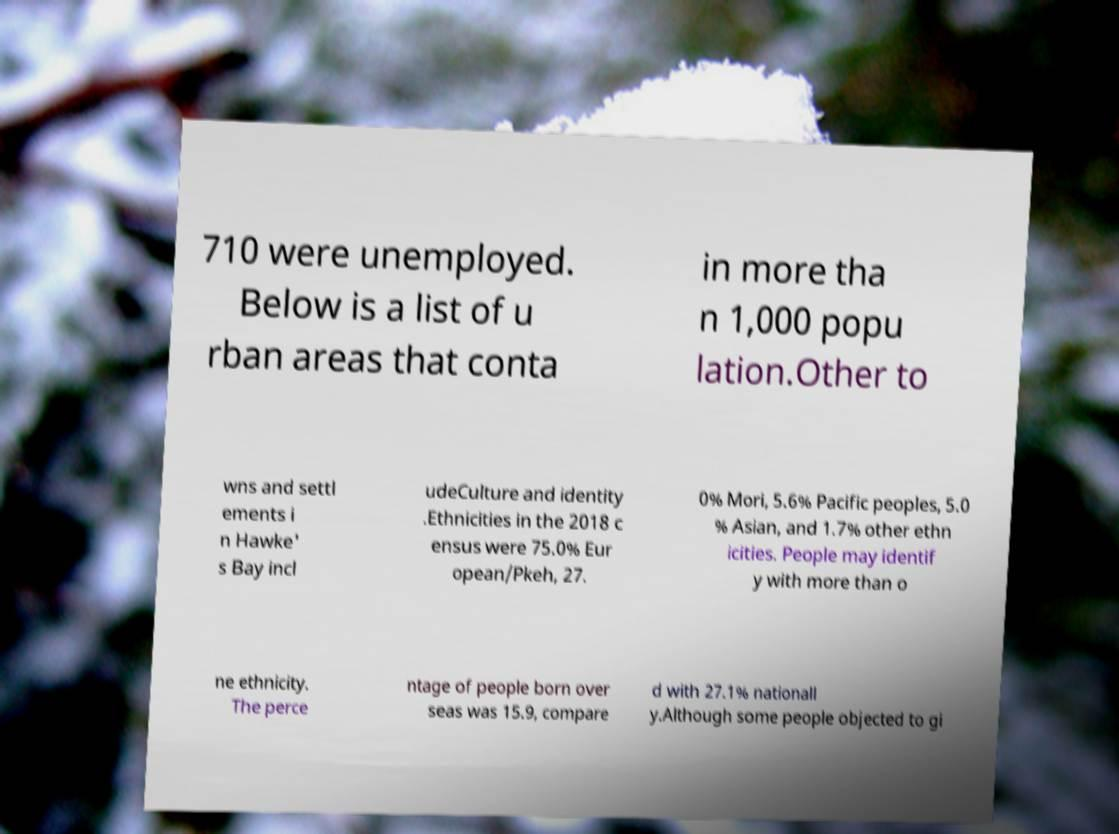There's text embedded in this image that I need extracted. Can you transcribe it verbatim? 710 were unemployed. Below is a list of u rban areas that conta in more tha n 1,000 popu lation.Other to wns and settl ements i n Hawke' s Bay incl udeCulture and identity .Ethnicities in the 2018 c ensus were 75.0% Eur opean/Pkeh, 27. 0% Mori, 5.6% Pacific peoples, 5.0 % Asian, and 1.7% other ethn icities. People may identif y with more than o ne ethnicity. The perce ntage of people born over seas was 15.9, compare d with 27.1% nationall y.Although some people objected to gi 